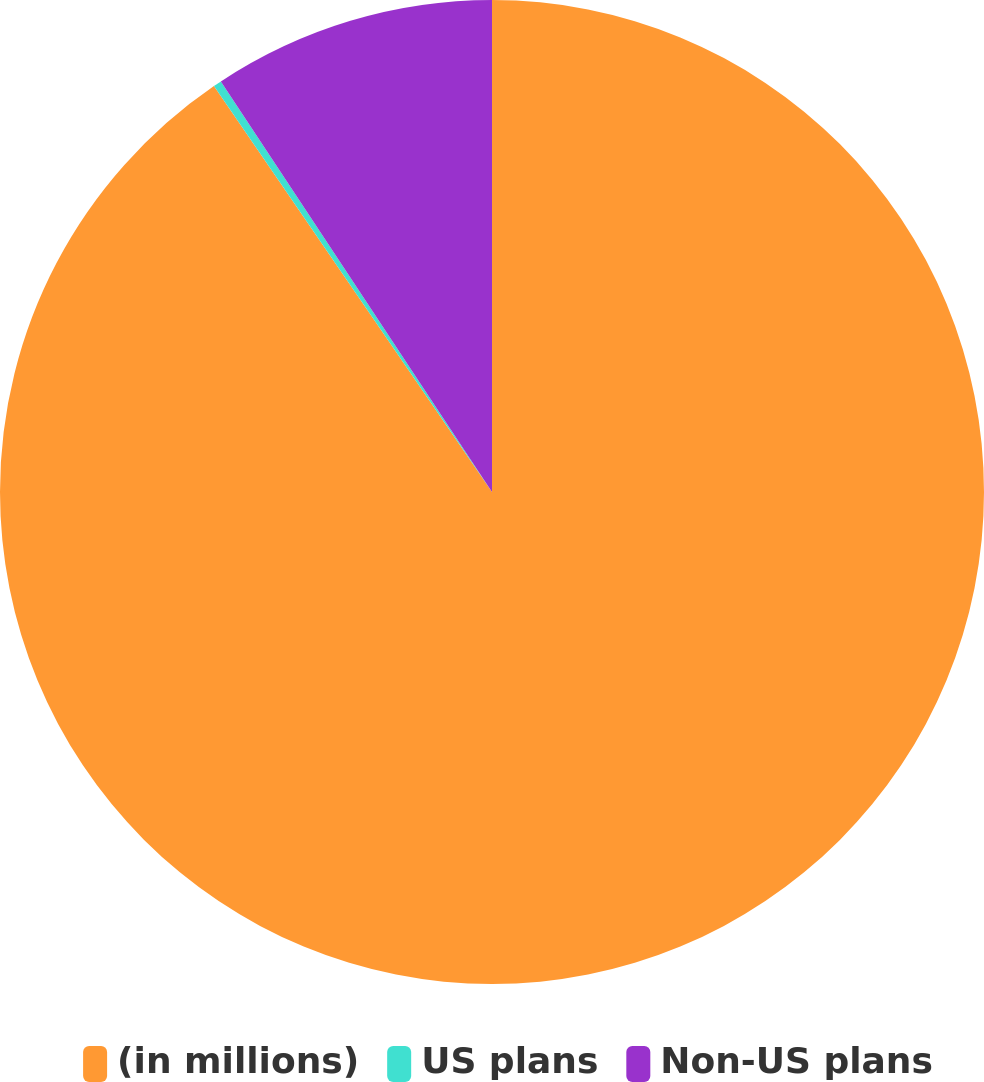<chart> <loc_0><loc_0><loc_500><loc_500><pie_chart><fcel>(in millions)<fcel>US plans<fcel>Non-US plans<nl><fcel>90.44%<fcel>0.27%<fcel>9.29%<nl></chart> 